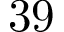<formula> <loc_0><loc_0><loc_500><loc_500>3 9</formula> 